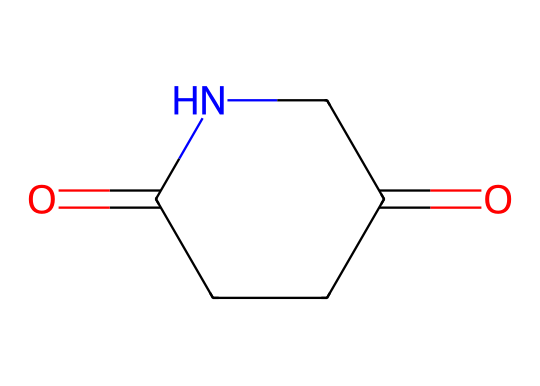What is the molecular formula of glutarimide? To determine the molecular formula from the SMILES notation, we decipher it to find the number of each type of atom present. The SMILES notation indicates there are 5 carbon atoms (C), 7 hydrogen atoms (H), 2 oxygen atoms (O), and 1 nitrogen atom (N). Therefore, the molecular formula is C5H7N2O2.
Answer: C5H7N2O2 How many rings are present in glutarimide? Looking at the structure depicted by the SMILES, we can see that there is a cyclization indicated by 'C1...C1', suggesting that there is one ring structure present.
Answer: 1 What type of chemical is glutarimide? Glutarimide is classified as an imide due to its structural features, specifically the presence of the functional group derived from two carbonyl groups and a nitrogen atom bonded to the carbon chain.
Answer: imide What types of functional groups are present in glutarimide? The structure reveals two carbonyl (C=O) groups and an amine (C-N) group, characteristic of an imide. Thus, the functional groups in glutarimide are imide and carbonyl.
Answer: imide and carbonyl How many hydrogen atoms are connected to the nitrogen in glutarimide? By analyzing the structure, we see that the nitrogen atom has one hydrogen atom attached; it doesn't have additional hydrogen atoms since it's involved in forming the ring structure.
Answer: 1 